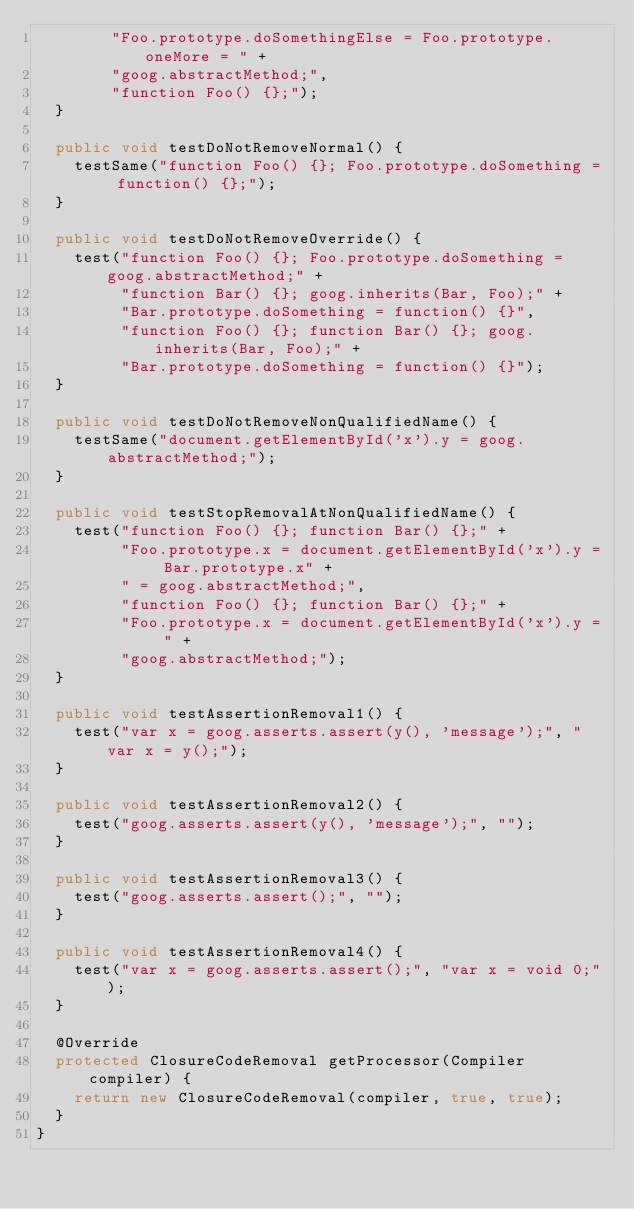<code> <loc_0><loc_0><loc_500><loc_500><_Java_>        "Foo.prototype.doSomethingElse = Foo.prototype.oneMore = " +
        "goog.abstractMethod;",
        "function Foo() {};");
  }

  public void testDoNotRemoveNormal() {
    testSame("function Foo() {}; Foo.prototype.doSomething = function() {};");
  }

  public void testDoNotRemoveOverride() {
    test("function Foo() {}; Foo.prototype.doSomething = goog.abstractMethod;" +
         "function Bar() {}; goog.inherits(Bar, Foo);" +
         "Bar.prototype.doSomething = function() {}",
         "function Foo() {}; function Bar() {}; goog.inherits(Bar, Foo);" +
         "Bar.prototype.doSomething = function() {}");
  }

  public void testDoNotRemoveNonQualifiedName() {
    testSame("document.getElementById('x').y = goog.abstractMethod;");
  }

  public void testStopRemovalAtNonQualifiedName() {
    test("function Foo() {}; function Bar() {};" +
         "Foo.prototype.x = document.getElementById('x').y = Bar.prototype.x" +
         " = goog.abstractMethod;",
         "function Foo() {}; function Bar() {};" +
         "Foo.prototype.x = document.getElementById('x').y = " +
         "goog.abstractMethod;");
  }

  public void testAssertionRemoval1() {
    test("var x = goog.asserts.assert(y(), 'message');", "var x = y();");
  }

  public void testAssertionRemoval2() {
    test("goog.asserts.assert(y(), 'message');", "");
  }

  public void testAssertionRemoval3() {
    test("goog.asserts.assert();", "");
  }

  public void testAssertionRemoval4() {
    test("var x = goog.asserts.assert();", "var x = void 0;");
  }

  @Override
  protected ClosureCodeRemoval getProcessor(Compiler compiler) {
    return new ClosureCodeRemoval(compiler, true, true);
  }
}
</code> 